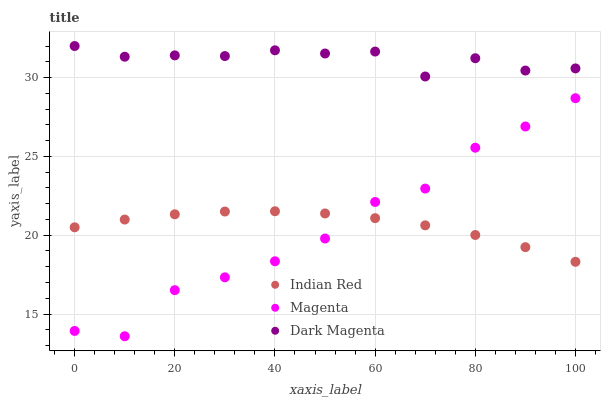Does Magenta have the minimum area under the curve?
Answer yes or no. Yes. Does Dark Magenta have the maximum area under the curve?
Answer yes or no. Yes. Does Indian Red have the minimum area under the curve?
Answer yes or no. No. Does Indian Red have the maximum area under the curve?
Answer yes or no. No. Is Indian Red the smoothest?
Answer yes or no. Yes. Is Magenta the roughest?
Answer yes or no. Yes. Is Dark Magenta the smoothest?
Answer yes or no. No. Is Dark Magenta the roughest?
Answer yes or no. No. Does Magenta have the lowest value?
Answer yes or no. Yes. Does Indian Red have the lowest value?
Answer yes or no. No. Does Dark Magenta have the highest value?
Answer yes or no. Yes. Does Indian Red have the highest value?
Answer yes or no. No. Is Indian Red less than Dark Magenta?
Answer yes or no. Yes. Is Dark Magenta greater than Indian Red?
Answer yes or no. Yes. Does Magenta intersect Indian Red?
Answer yes or no. Yes. Is Magenta less than Indian Red?
Answer yes or no. No. Is Magenta greater than Indian Red?
Answer yes or no. No. Does Indian Red intersect Dark Magenta?
Answer yes or no. No. 